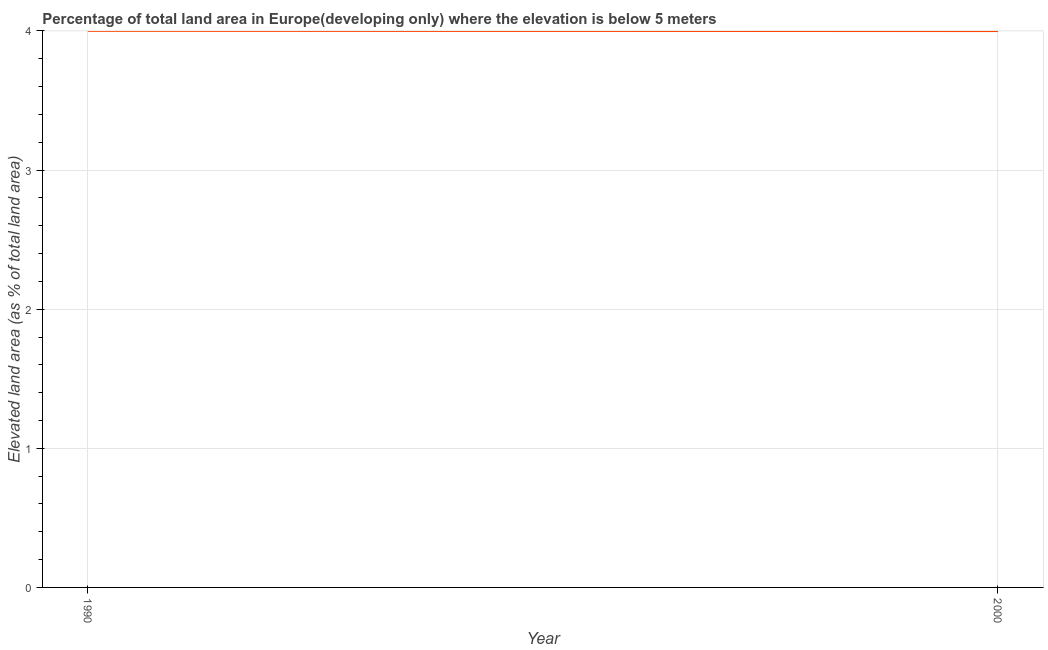What is the total elevated land area in 1990?
Provide a succinct answer. 4. Across all years, what is the maximum total elevated land area?
Give a very brief answer. 4. Across all years, what is the minimum total elevated land area?
Give a very brief answer. 4. What is the sum of the total elevated land area?
Your answer should be compact. 8. What is the difference between the total elevated land area in 1990 and 2000?
Offer a terse response. 0. What is the average total elevated land area per year?
Provide a succinct answer. 4. What is the median total elevated land area?
Keep it short and to the point. 4. Do a majority of the years between 1990 and 2000 (inclusive) have total elevated land area greater than 3.8 %?
Give a very brief answer. Yes. What is the ratio of the total elevated land area in 1990 to that in 2000?
Your answer should be very brief. 1. In how many years, is the total elevated land area greater than the average total elevated land area taken over all years?
Give a very brief answer. 1. How many lines are there?
Give a very brief answer. 1. Are the values on the major ticks of Y-axis written in scientific E-notation?
Make the answer very short. No. What is the title of the graph?
Keep it short and to the point. Percentage of total land area in Europe(developing only) where the elevation is below 5 meters. What is the label or title of the X-axis?
Provide a succinct answer. Year. What is the label or title of the Y-axis?
Your answer should be very brief. Elevated land area (as % of total land area). What is the Elevated land area (as % of total land area) of 1990?
Keep it short and to the point. 4. What is the Elevated land area (as % of total land area) of 2000?
Offer a terse response. 4. What is the difference between the Elevated land area (as % of total land area) in 1990 and 2000?
Make the answer very short. 0. 